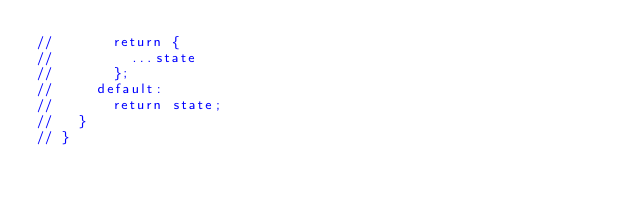Convert code to text. <code><loc_0><loc_0><loc_500><loc_500><_TypeScript_>//       return {
//         ...state
//       };
//     default:
//       return state;
//   }
// }
</code> 